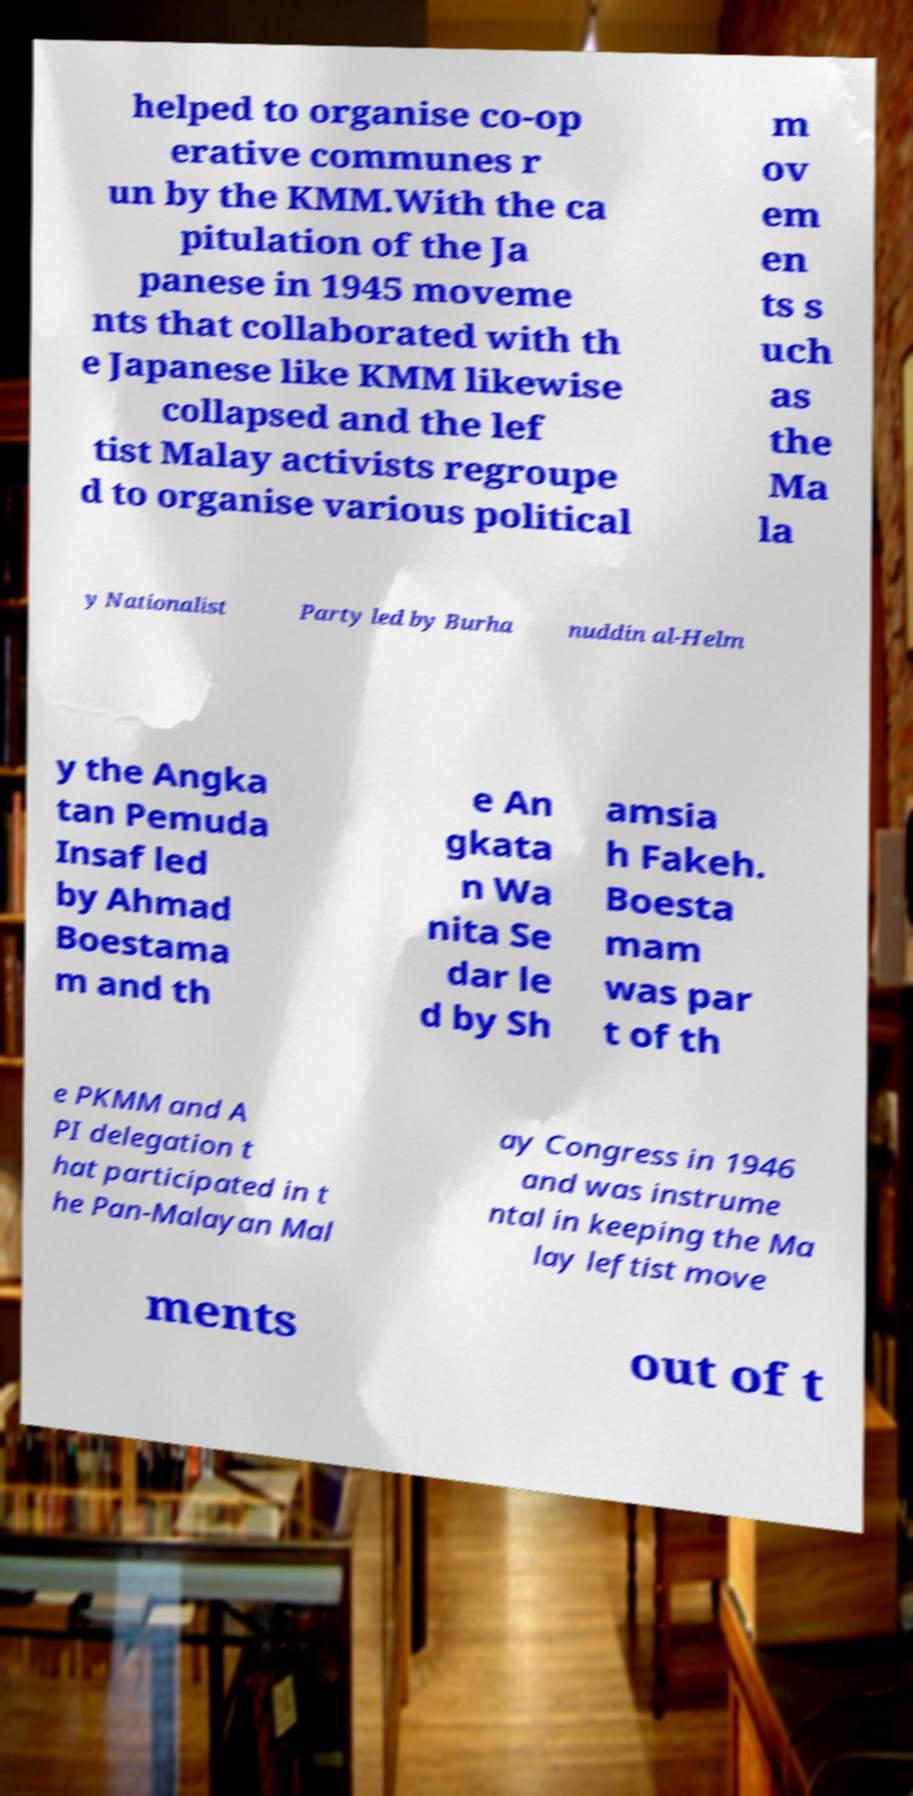Please read and relay the text visible in this image. What does it say? helped to organise co-op erative communes r un by the KMM.With the ca pitulation of the Ja panese in 1945 moveme nts that collaborated with th e Japanese like KMM likewise collapsed and the lef tist Malay activists regroupe d to organise various political m ov em en ts s uch as the Ma la y Nationalist Party led by Burha nuddin al-Helm y the Angka tan Pemuda Insaf led by Ahmad Boestama m and th e An gkata n Wa nita Se dar le d by Sh amsia h Fakeh. Boesta mam was par t of th e PKMM and A PI delegation t hat participated in t he Pan-Malayan Mal ay Congress in 1946 and was instrume ntal in keeping the Ma lay leftist move ments out of t 